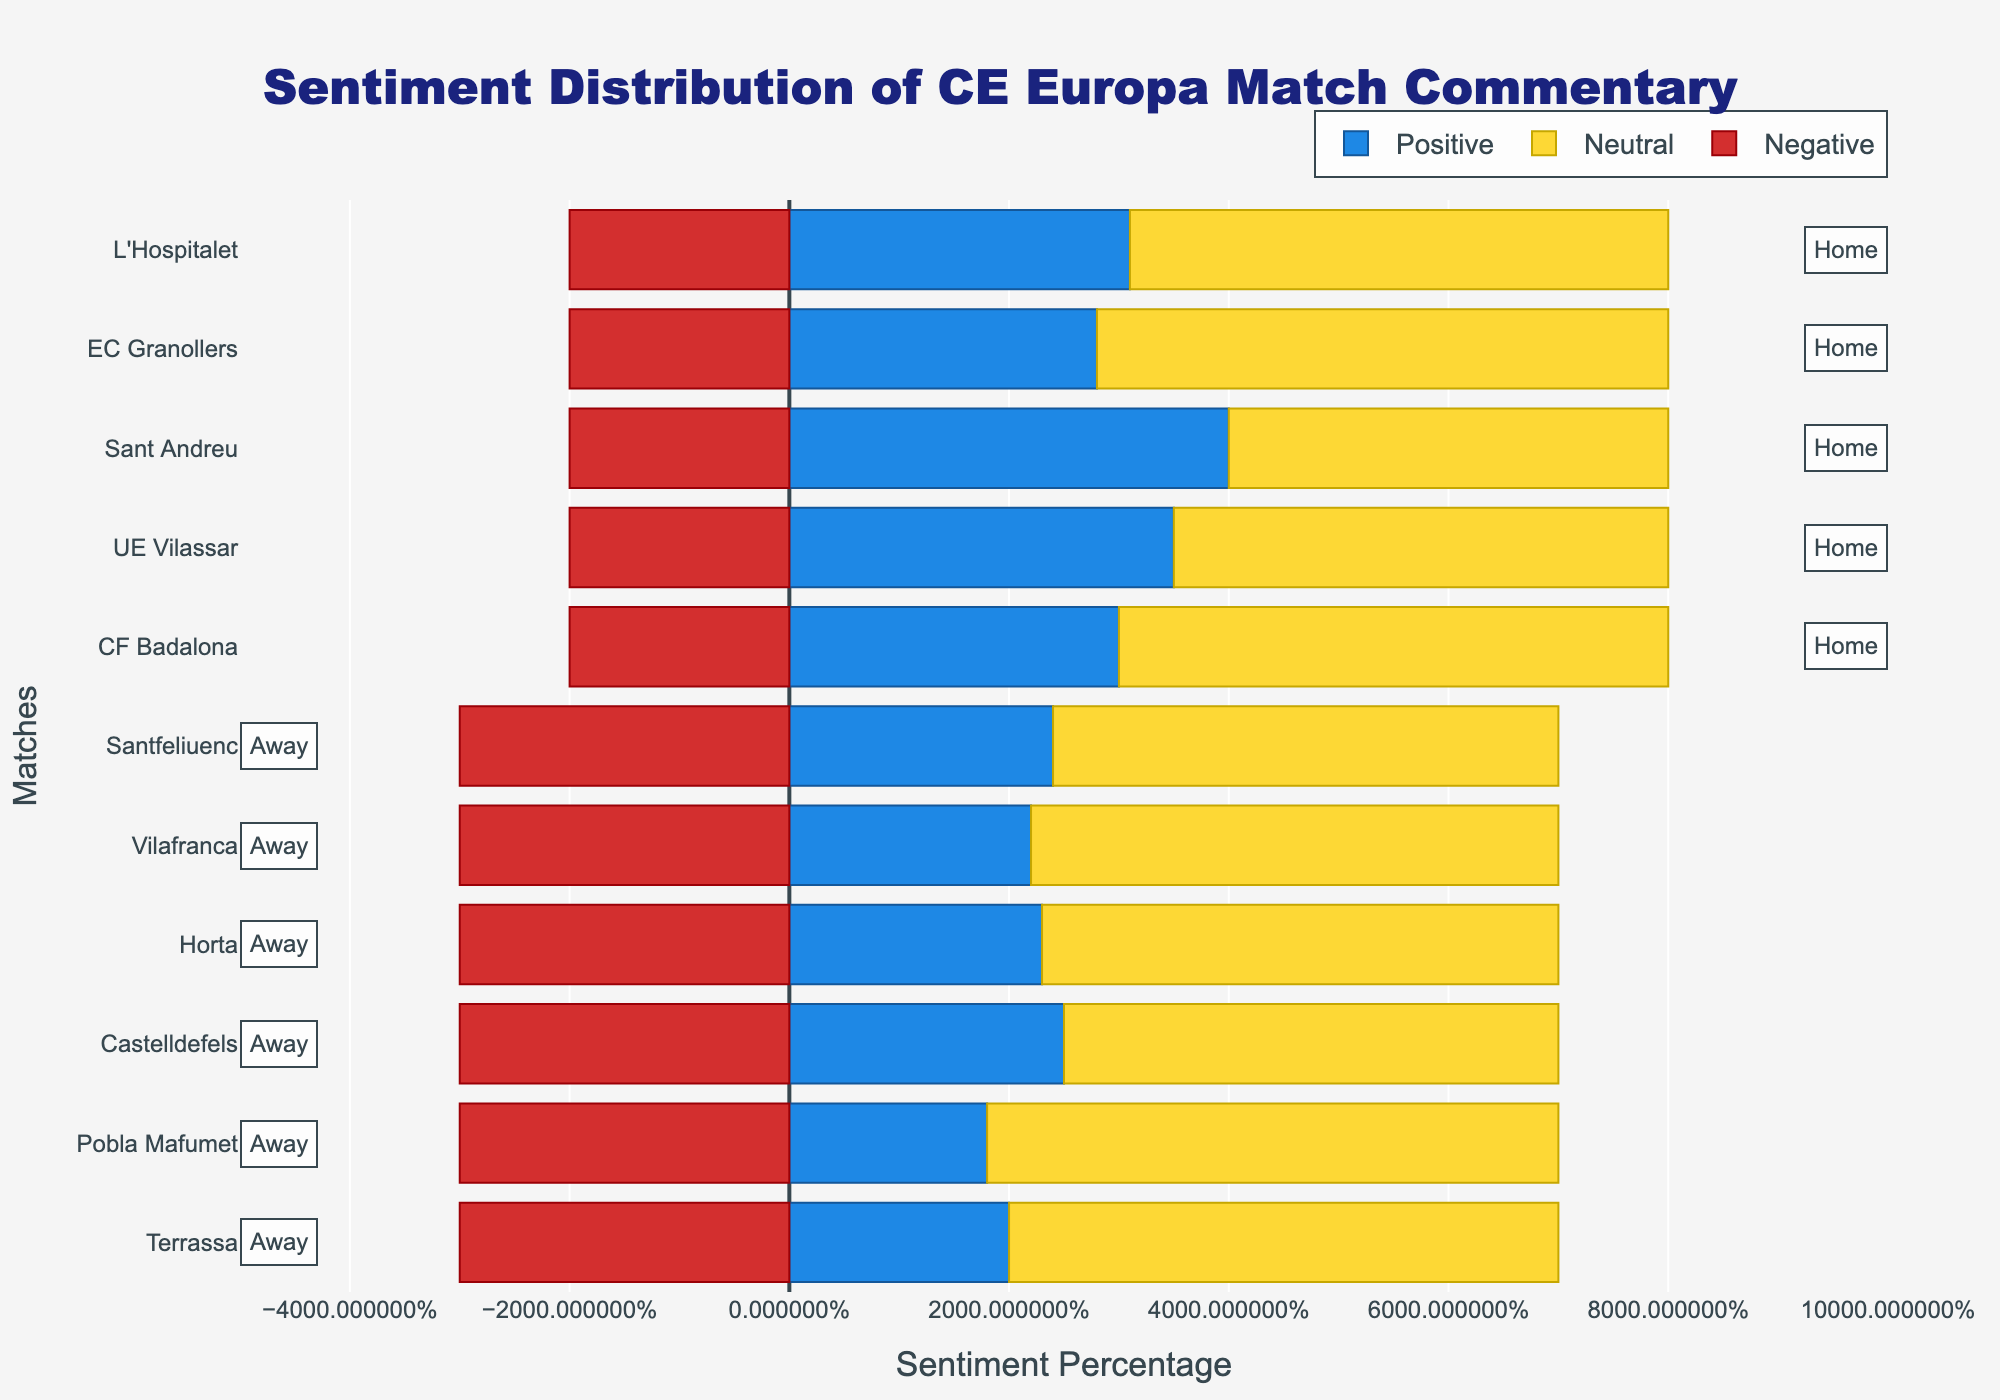Which match has the highest percentage of positive commentary? To determine which match has the highest percentage of positive commentary, scan the figure for the tallest blue bar. The highest blue bar corresponds to "CE Europa vs Sant Andreu" with 40% positive commentary.
Answer: CE Europa vs Sant Andreu What's the average positive sentiment for home matches? First, identify the positive sentiment percentages for every home match: 30, 35, 40, 28, 31. Sum these values to get 164, and divide by the number of home matches (5). The average is 164/5 = 32.8.
Answer: 32.8 Which location generally has a higher negative sentiment? Compare the negative sentiment percentages for home and away matches. Home matches consistently show a negative sentiment of 20%, whereas away matches consistently show 30%. The away matches have a higher negative sentiment.
Answer: Away Compare the neutral sentiment between CE Europa vs UE Vilassar and CE Europa vs Terrassa. Which match has a higher neutral sentiment? Compare the yellow bars for the two matches. "CE Europa vs UE Vilassar" has a neutral sentiment of 45%, while "CE Europa vs Terrassa" has a neutral sentiment of 50%. Therefore, "CE Europa vs Terrassa" has a higher neutral sentiment.
Answer: CE Europa vs Terrassa What is the total negative sentiment for all away matches? Identify the negative sentiment for each away match (30, 30, 30, 30, 30, 30), sum these values to get a total of 180.
Answer: 180 Describe the difference in neutral sentiment for CE Europa vs CF Badalona and CE Europa vs Vilafranca. Look at the yellow bars for both matches. CE Europa vs CF Badalona has 50% neutral sentiment, and CE Europa vs Vilafranca has 48%. The difference is 50% - 48% = 2%.
Answer: 2% What's the ratio of positive to negative sentiment for CE Europa vs Santfeliuenc? For CE Europa vs Santfeliuenc, the positive sentiment is 24% and the negative sentiment is 30%. The ratio is 24/30, which simplifies to 4/5 or 0.80.
Answer: 0.80 Which location has the more consistent neutral sentiment, home or away? Observe the variation in yellow bars for both locations. Home matches show neutral percentages of 50, 45, 40, 52, 49, while away matches show more consistent neutral percentages—mostly around 46-52. The away matches are more consistent.
Answer: Away How does the neutral sentiment compare on average between home and away matches? First, calculate the average neutral sentiment for home matches: (50+45+40+52+49)/5 = 47.2. Then, for away matches: (50+52+45+47+48+46)/6 = 48.0. Compare the two averages, the neutral sentiment is slightly higher for away matches by 0.8.
Answer: 0.8 